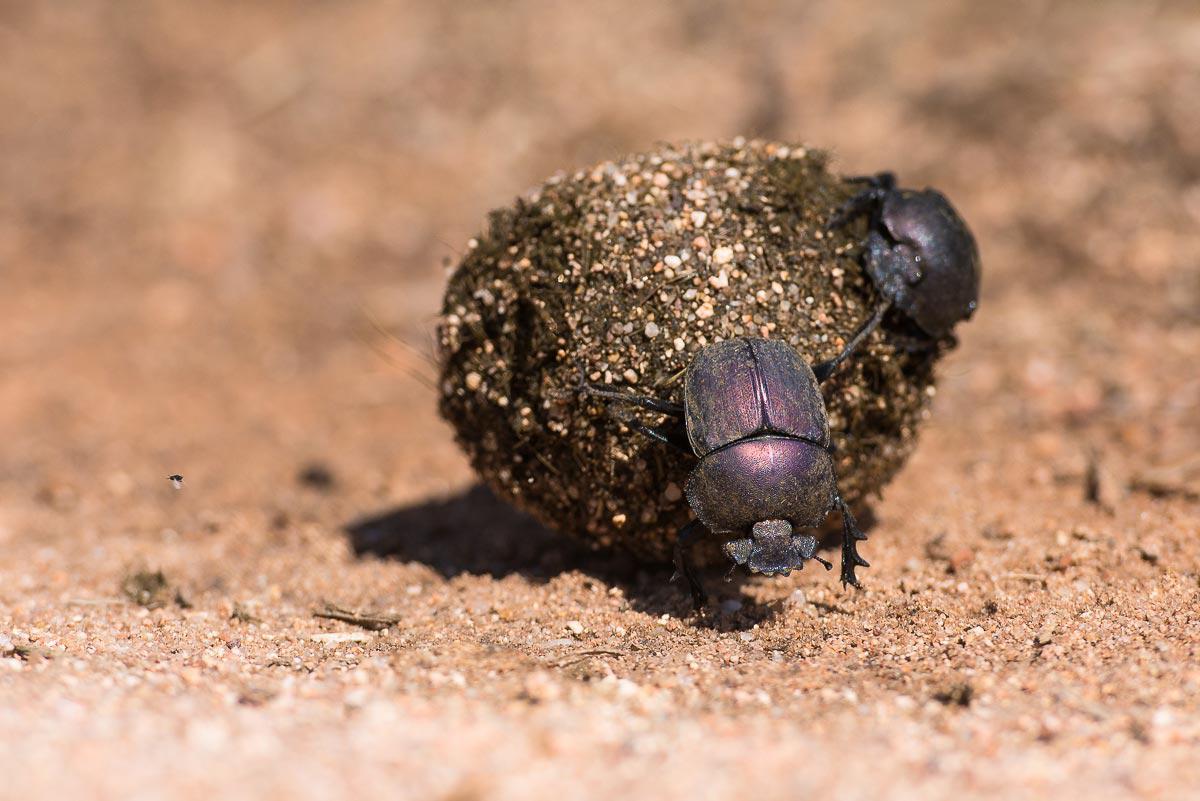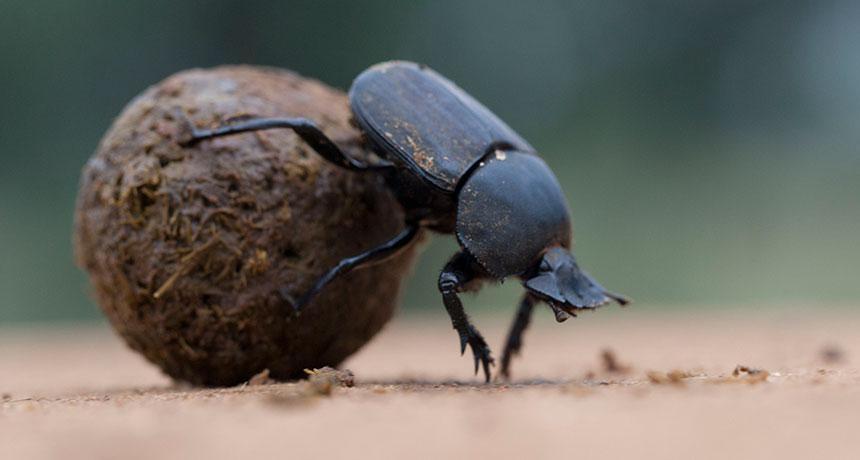The first image is the image on the left, the second image is the image on the right. Assess this claim about the two images: "The image on the left contains exactly one insect.". Correct or not? Answer yes or no. No. 